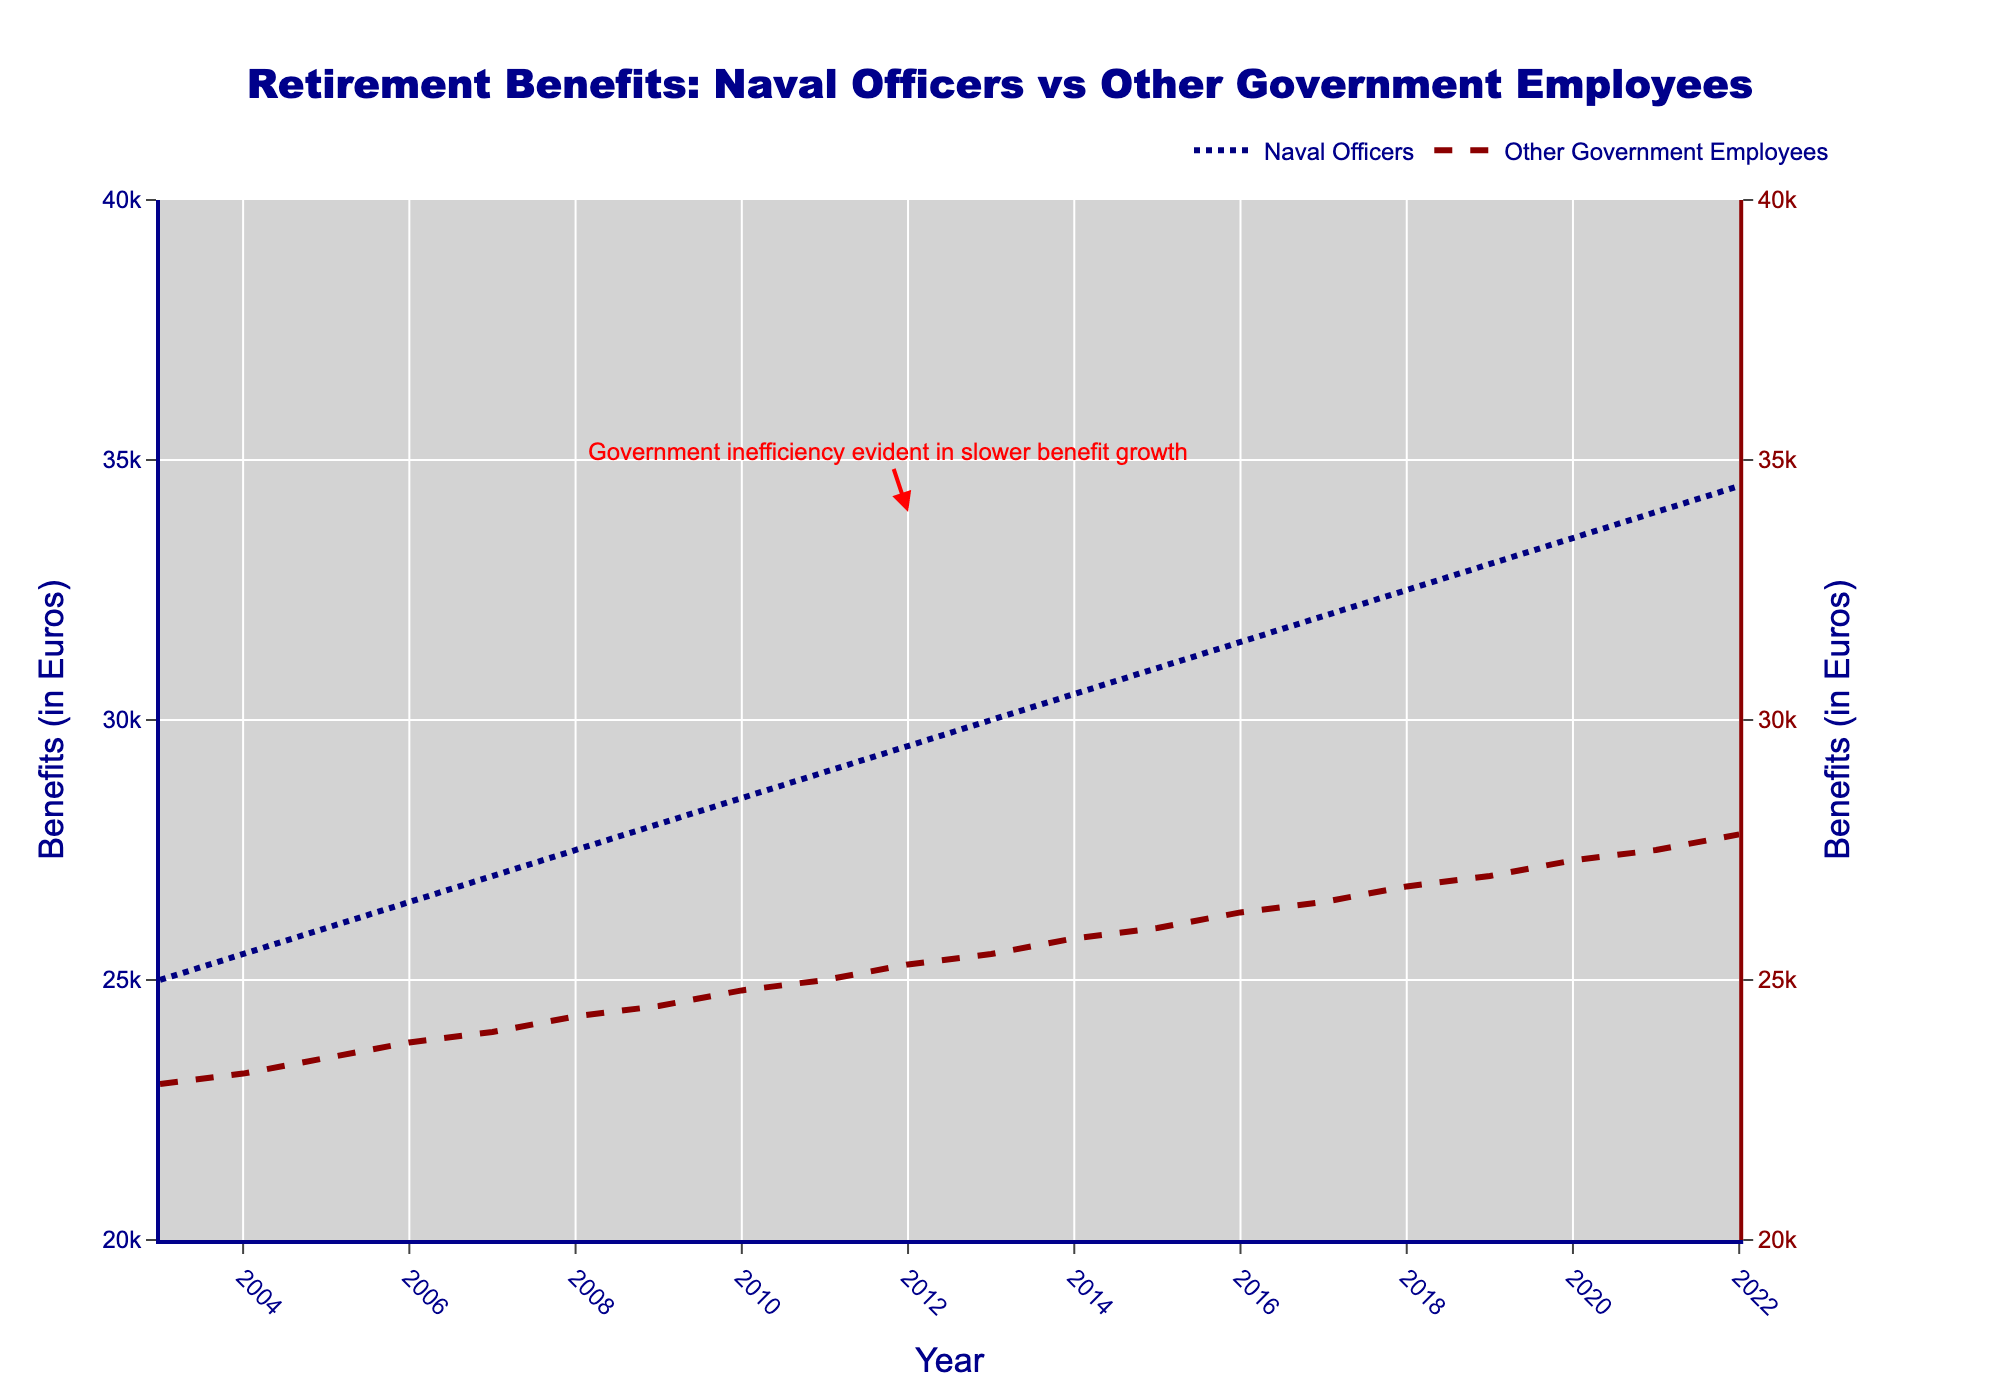What is the title of the plot? The title is displayed at the top of the plot.
Answer: "Retirement Benefits: Naval Officers vs Other Government Employees" How many years does the plot cover? The x-axis shows the years, spanning from the first to the last data point. Counting the years from 2003 to 2022 gives a total number of years covered.
Answer: 20 years What is the range of retirement benefits for Dutch Naval Officers in the plot? Look at the y-axis corresponding to the Dutch Naval Officers and identify the minimum and maximum values on that axis. The benefits range from 25,000 Euros to 34,500 Euros.
Answer: 25,000 to 34,500 Euros Which year has the largest difference between the retirement benefits of Dutch Naval Officers and Other Government Employees? To find this, subtract the benefits of the Other Government Employees from the benefits of Dutch Naval Officers for each year. The year with the highest difference is the one with the largest subtraction result.
Answer: 2022 What is the trend in retirement benefits for Dutch Naval Officers over the 20 years? Observe the line representing Dutch Naval Officers. It shows an upward trend, indicating that the benefits have increased over the years.
Answer: Increasing trend In 2016, how much higher were the retirement benefits for Dutch Naval Officers compared to Other Government Employees? Look at the y-axis values for both groups in 2016. For Dutch Naval Officers, it's 31,500 Euros, and for Other Government Employees, it’s 26,300 Euros. Subtract the latter from the former to get the difference. 31,500 - 26,300 = 5,200 Euros.
Answer: 5,200 Euros Which group experienced a slower growth in benefits over the years, according to the annotation? The annotation text "Government inefficiency evident in slower benefit growth" points to Other Government Employees. This indicates that the other government employees had slower benefit growth.
Answer: Other Government Employees What is the average increase in retirement benefits for Dutch Naval Officers per year? Calculate the total increase over the 20 years and divide by the number of years. The increase from 25,000 Euros in 2003 to 34,500 Euros in 2022 is 34,500 - 25,000 = 9,500 Euros. Divide by the 20-year period: 9,500 / 20 = 475 Euros per year.
Answer: 475 Euros per year Comparing the years 2008 and 2018, how much did the retirement benefits for Other Government Employees increase? Look at the benefits for Other Government Employees in 2008 (24,300 Euros) and 2018 (26,800 Euros). Subtract the 2008 value from the 2018 value: 26,800 - 24,300 = 2,500 Euros.
Answer: 2,500 Euros What colors are used to represent Dutch Naval Officers and Other Government Employees? The plot uses different line colors for each group. The Dutch Naval Officers are represented in navy, and the Other Government Employees in dark red.
Answer: Navy and dark red 